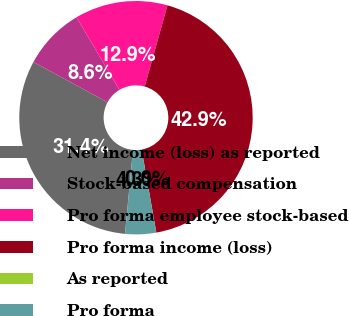Convert chart to OTSL. <chart><loc_0><loc_0><loc_500><loc_500><pie_chart><fcel>Net income (loss) as reported<fcel>Stock-based compensation<fcel>Pro forma employee stock-based<fcel>Pro forma income (loss)<fcel>As reported<fcel>Pro forma<nl><fcel>31.42%<fcel>8.57%<fcel>12.86%<fcel>42.86%<fcel>0.0%<fcel>4.29%<nl></chart> 